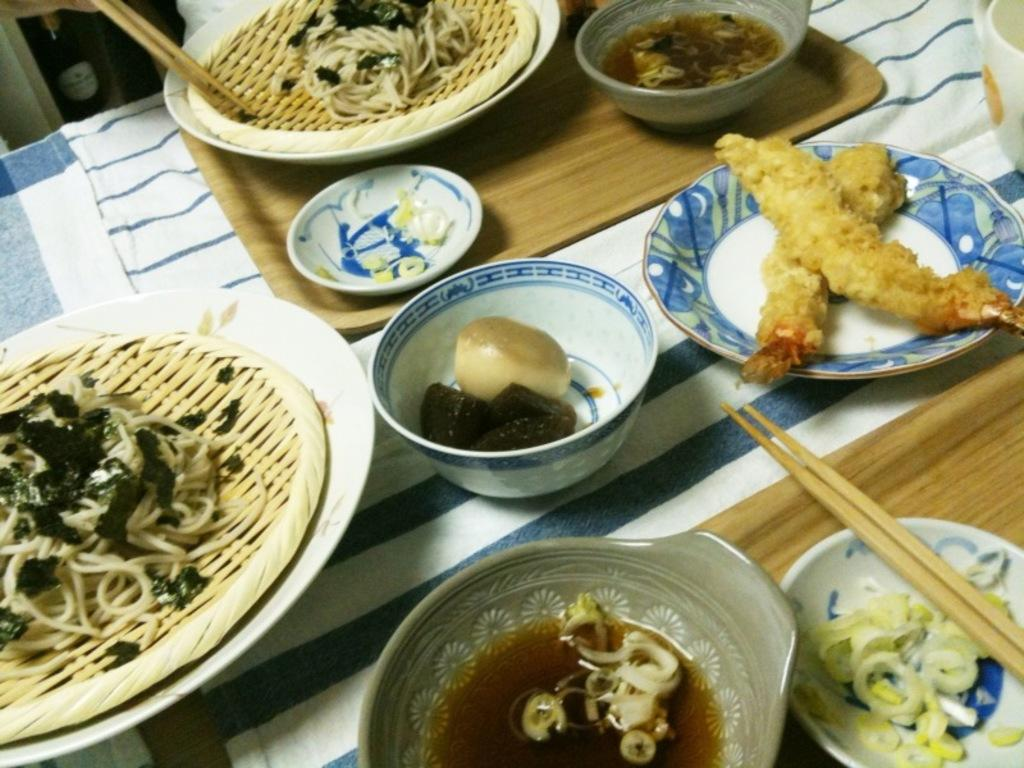Where was the image taken? The image is taken indoors. What can be seen on the table in the image? There are platters and bowls containing food items on the table. How is the table positioned in the image? The table is in the center of the image. What can be seen in the background of the image? There are objects visible in the background of the image. Can you hear the cattle whistling in the image? There is no mention of cattle or whistling in the image; it only shows a table with food items and objects in the background. 